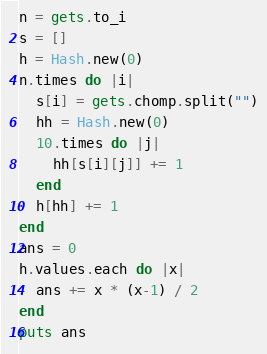Convert code to text. <code><loc_0><loc_0><loc_500><loc_500><_Ruby_>n = gets.to_i
s = []
h = Hash.new(0)
n.times do |i|
  s[i] = gets.chomp.split("")
  hh = Hash.new(0)
  10.times do |j|
    hh[s[i][j]] += 1
  end
  h[hh] += 1
end
ans = 0
h.values.each do |x|
  ans += x * (x-1) / 2
end
puts ans</code> 